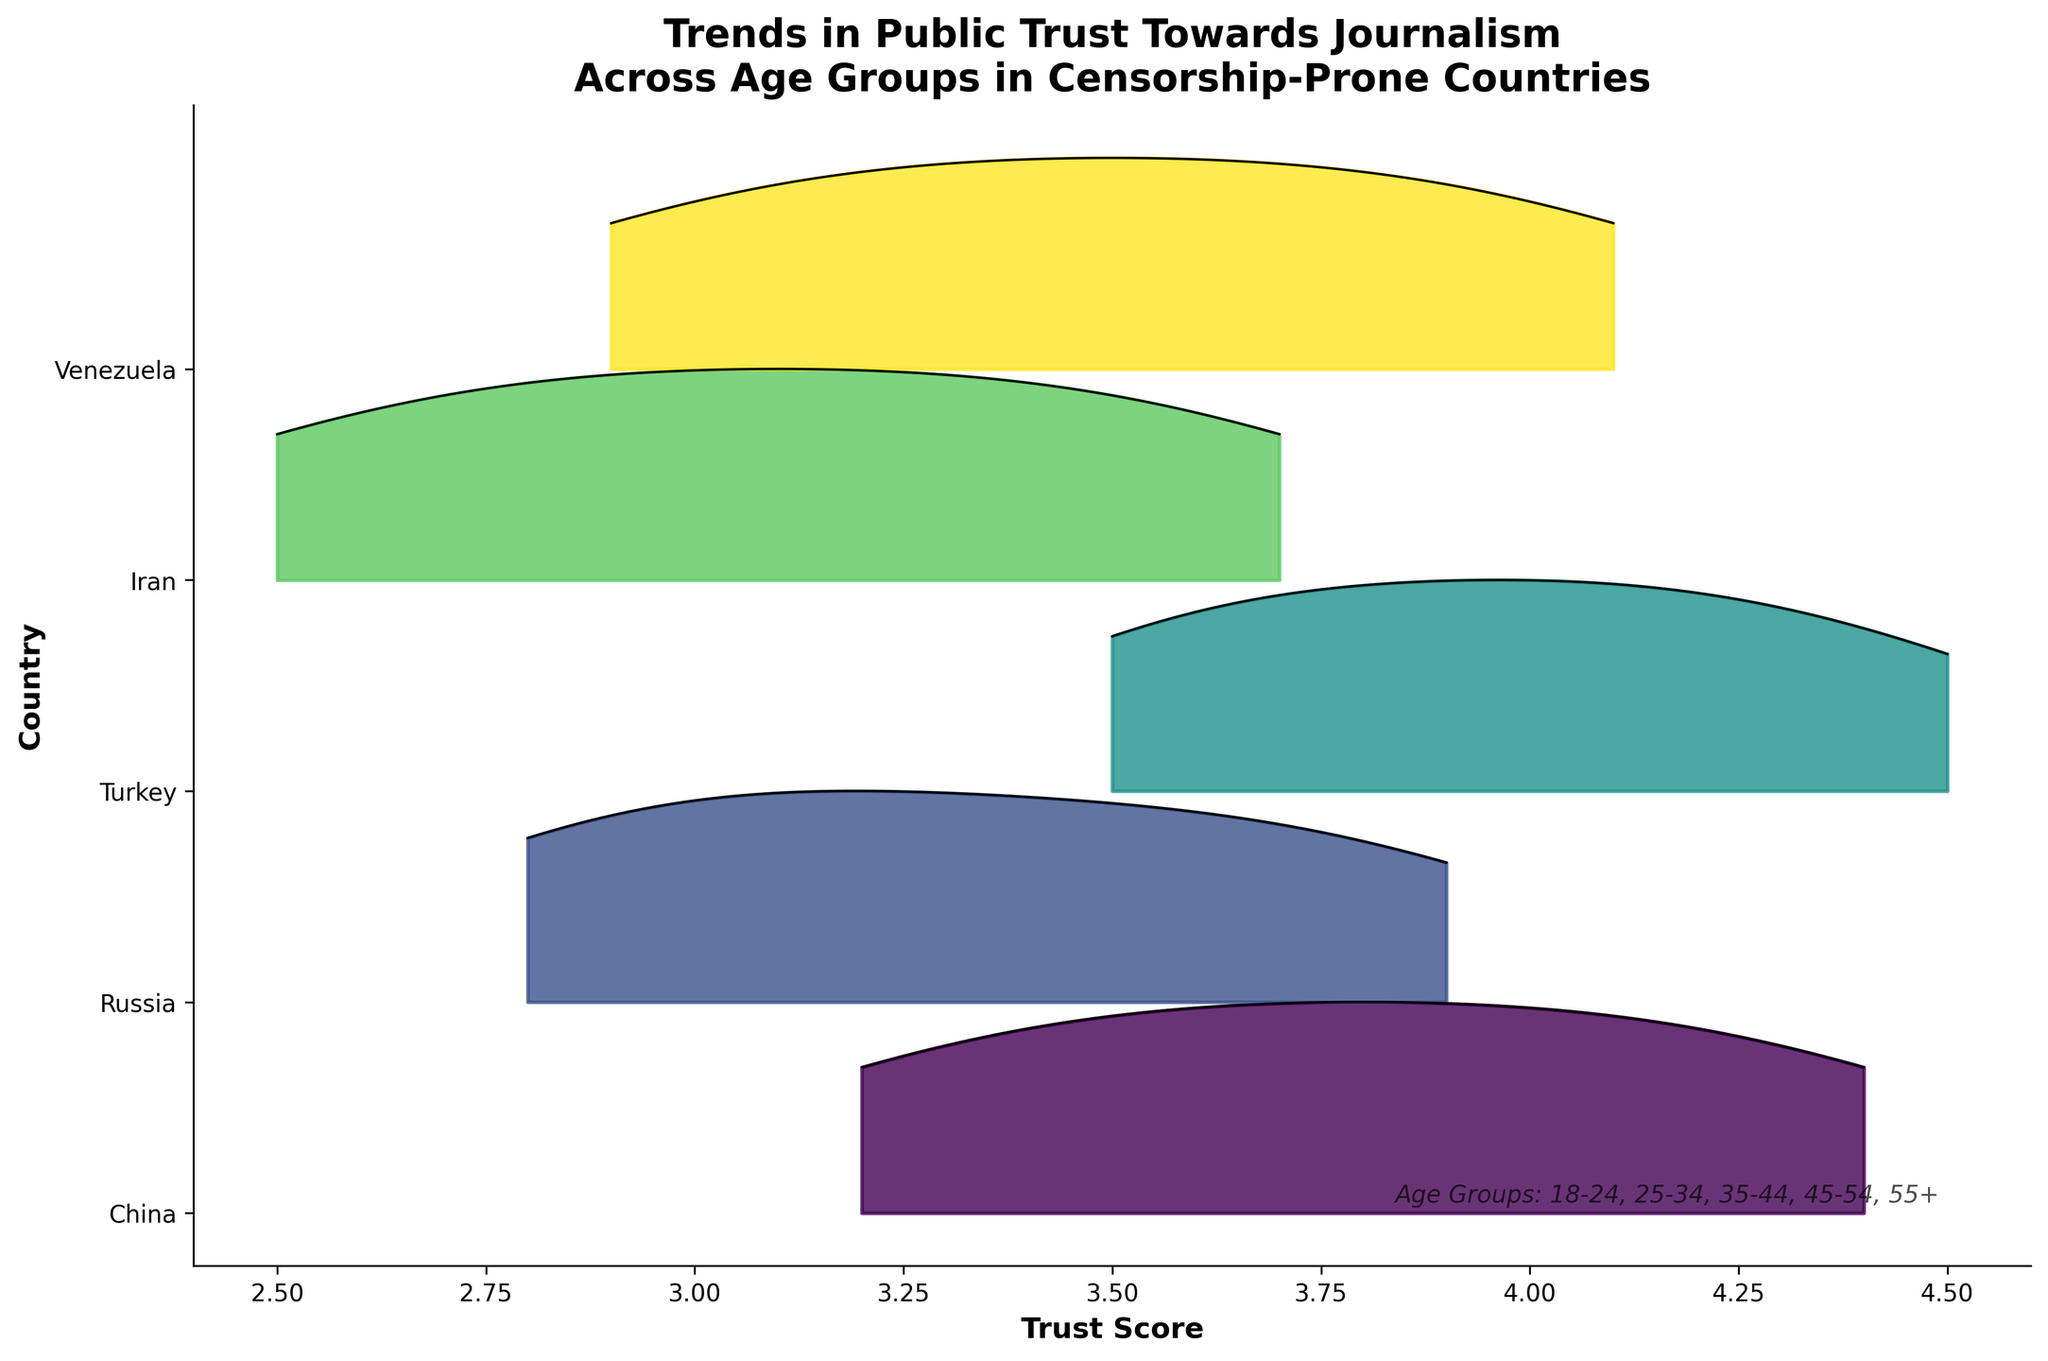What is the title of the figure? The title is displayed at the top of the figure and provides a summary of what the plot is about. The title reads "Trends in Public Trust Towards Journalism Across Age Groups in Censorship-Prone Countries."
Answer: Trends in Public Trust Towards Journalism Across Age Groups in Censorship-Prone Countries Which country has the lowest trust score among the oldest age group (55+)? By examining the lowest ridgeline for the 55+ age group, Iran shows the lowest trust score.
Answer: Iran Among the age group 25-34, which country shows the highest trust score? By comparing the ridgeline heights for the 25-34 age group across all countries, Turkey has the highest peak.
Answer: Turkey How does the trust score trend change as age increases in Venezuela? The trust score in Venezuela increases consistently across all age groups from 18-24 to 55+.
Answer: It increases Which country displays the most dramatic increase in trust scores from age group 18-24 to 55+? By comparing the total increase in trust scores from 18-24 to 55+ for each country, Turkey shows the most significant increase.
Answer: Turkey What general trend is observed for trust scores in journalism as age increases in censorship-prone countries? Across all displayed countries, as the age group increases, the trust scores generally rise.
Answer: Trust scores rise with age Among China, Russia, and Iran, which country has a higher trust score for the age group 35-44? Comparing the ridgelines for age group 35-44, China's trust score is highest among the three.
Answer: China How do the trust scores for Turkey and Venezuela compare for age group 55+? By inspecting the last age group's score for both countries, Turkey shows a slightly higher trust score than Venezuela.
Answer: Turkey has a higher score What can be inferred about younger people's trust in journalism in these countries? Examining the ridgelines for the 18-24 age group shows that younger people tend to have the lowest trust scores compared to older age groups in each country.
Answer: They have lower trust 